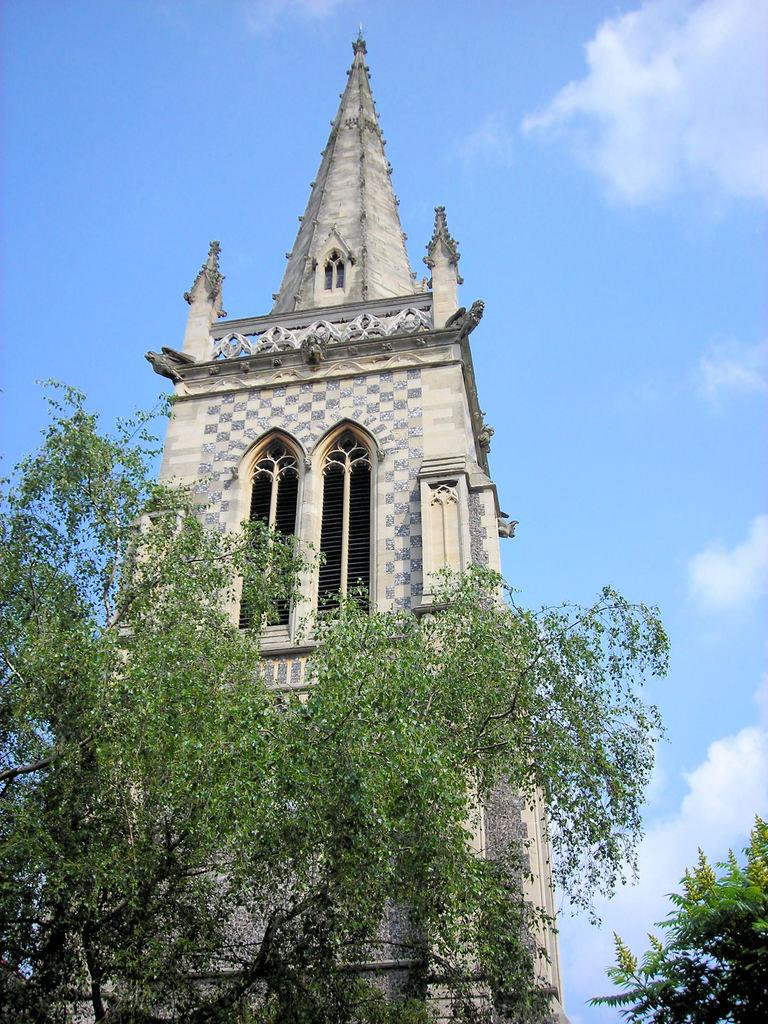What type of structure is present in the image? There is a building in the image. What other natural elements can be seen in the image? There are trees in the image. Are there any other objects or features visible in the image? Yes, there are other objects in the image. What can be seen in the background of the image? The sky is visible in the background of the image. How many beds are visible in the image? There are no beds present in the image. What type of connection can be seen between the building and the trees in the image? There is no visible connection between the building and the building and the trees in the image. 